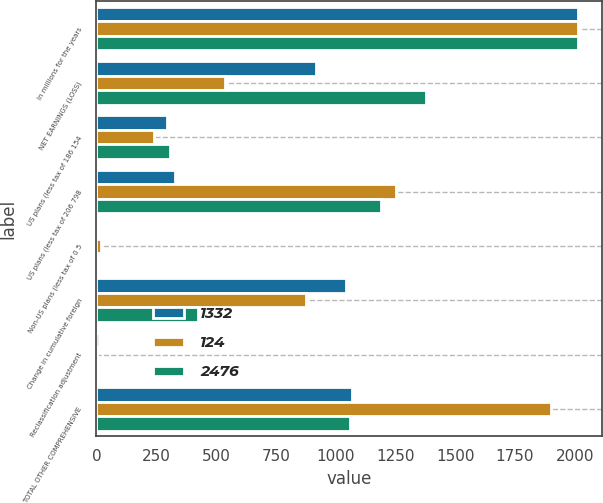Convert chart. <chart><loc_0><loc_0><loc_500><loc_500><stacked_bar_chart><ecel><fcel>In millions for the years<fcel>NET EARNINGS (LOSS)<fcel>US plans (less tax of 186 154<fcel>US plans (less tax of 206 798<fcel>Non-US plans (less tax of 0 5<fcel>Change in cumulative foreign<fcel>Reclassification adjustment<fcel>TOTAL OTHER COMPREHENSIVE<nl><fcel>1332<fcel>2015<fcel>917<fcel>296<fcel>329<fcel>2<fcel>1042<fcel>12<fcel>1068<nl><fcel>124<fcel>2014<fcel>536<fcel>242<fcel>1253<fcel>18<fcel>876<fcel>4<fcel>1899<nl><fcel>2476<fcel>2013<fcel>1378<fcel>307<fcel>1188<fcel>4<fcel>426<fcel>7<fcel>1058<nl></chart> 